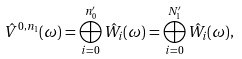Convert formula to latex. <formula><loc_0><loc_0><loc_500><loc_500>\hat { V } ^ { 0 , n _ { 1 } } ( \omega ) = \bigoplus _ { i = 0 } ^ { n ^ { \prime } _ { 0 } } \hat { W } _ { i } ( \omega ) = \bigoplus _ { i = 0 } ^ { N ^ { \prime } _ { 1 } } \hat { W } _ { i } ( \omega ) ,</formula> 